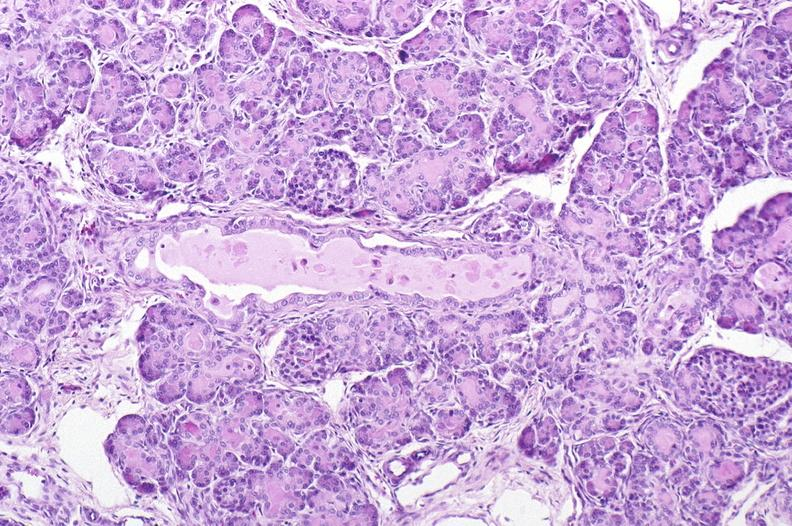what is present?
Answer the question using a single word or phrase. Pancreas 